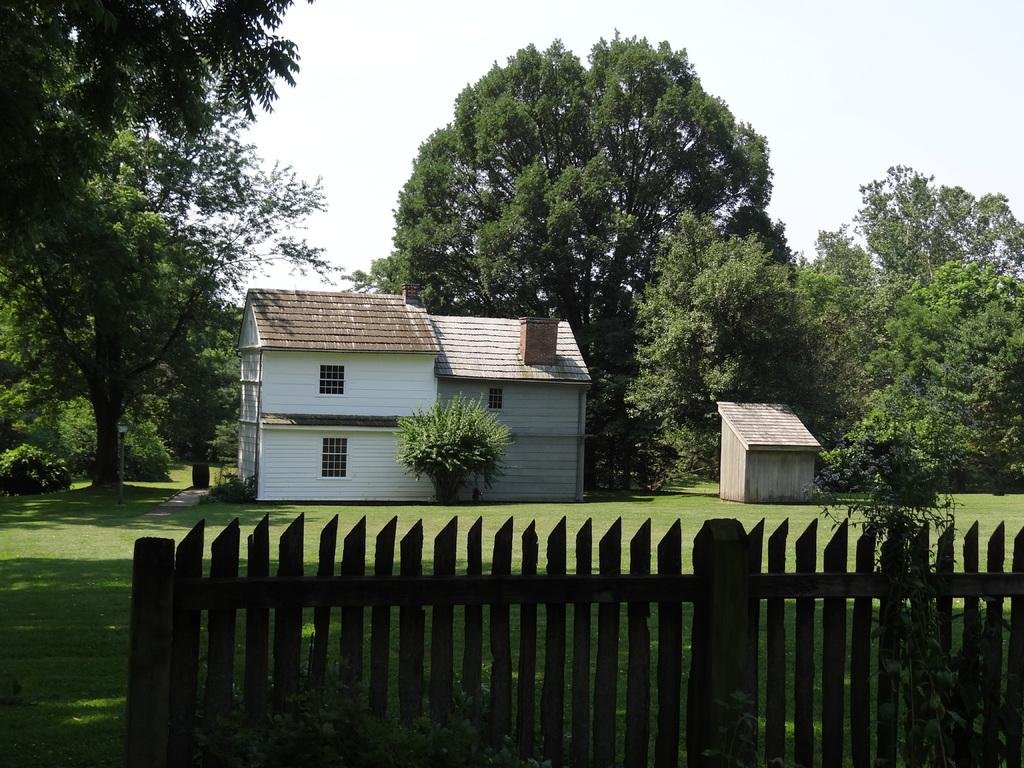What is located in the foreground of the image? There is a wooden fence in the foreground of the image. What structures can be seen in the background of the image? There is a building and a hut in the background of the image. What type of vegetation is visible in the background of the image? There are trees in the background of the image. What is the condition of the sky in the image? The sky is clear in the image. What type of industry is being taught in the hut in the image? There is no indication of any industry or teaching activity in the image; it simply shows a wooden fence, a building, a hut, trees, and a clear sky. 